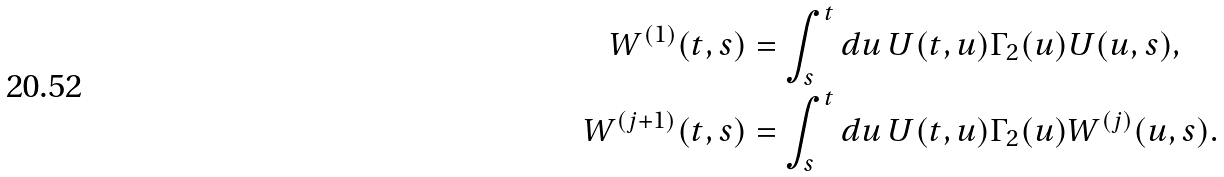Convert formula to latex. <formula><loc_0><loc_0><loc_500><loc_500>W ^ { ( 1 ) } ( t , s ) & = \int _ { s } ^ { t } { d u \, U ( t , u ) \Gamma _ { 2 } ( u ) U ( u , s ) } , \\ W ^ { ( j + 1 ) } ( t , s ) & = \int _ { s } ^ { t } { d u \, U ( t , u ) \Gamma _ { 2 } ( u ) W ^ { ( j ) } ( u , s ) } .</formula> 